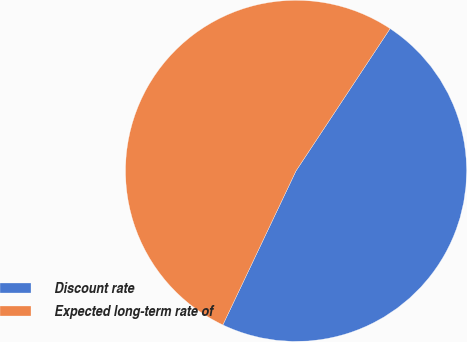Convert chart to OTSL. <chart><loc_0><loc_0><loc_500><loc_500><pie_chart><fcel>Discount rate<fcel>Expected long-term rate of<nl><fcel>47.76%<fcel>52.24%<nl></chart> 